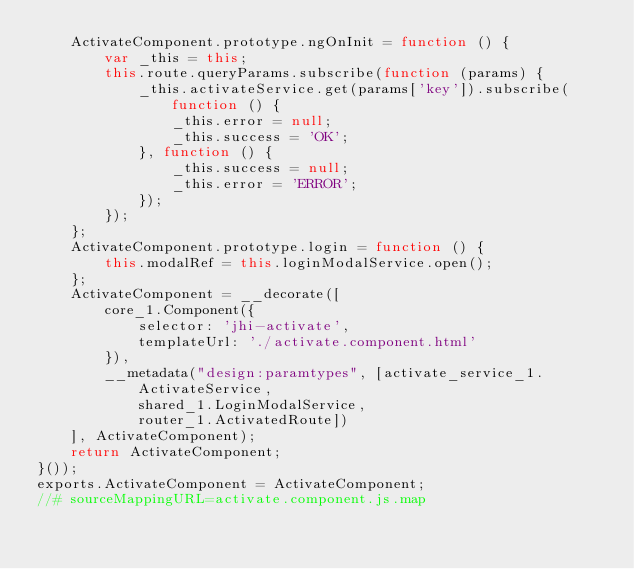Convert code to text. <code><loc_0><loc_0><loc_500><loc_500><_JavaScript_>    ActivateComponent.prototype.ngOnInit = function () {
        var _this = this;
        this.route.queryParams.subscribe(function (params) {
            _this.activateService.get(params['key']).subscribe(function () {
                _this.error = null;
                _this.success = 'OK';
            }, function () {
                _this.success = null;
                _this.error = 'ERROR';
            });
        });
    };
    ActivateComponent.prototype.login = function () {
        this.modalRef = this.loginModalService.open();
    };
    ActivateComponent = __decorate([
        core_1.Component({
            selector: 'jhi-activate',
            templateUrl: './activate.component.html'
        }),
        __metadata("design:paramtypes", [activate_service_1.ActivateService,
            shared_1.LoginModalService,
            router_1.ActivatedRoute])
    ], ActivateComponent);
    return ActivateComponent;
}());
exports.ActivateComponent = ActivateComponent;
//# sourceMappingURL=activate.component.js.map</code> 